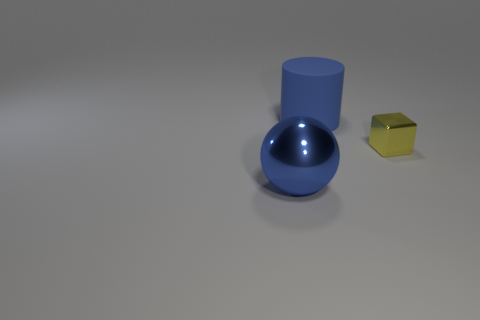How many objects are red cylinders or things that are right of the large metal ball?
Give a very brief answer. 2. Are the small thing and the big blue ball made of the same material?
Make the answer very short. Yes. Are there the same number of big blue things on the left side of the large blue metallic object and blue objects in front of the tiny metal thing?
Provide a short and direct response. No. What number of things are to the left of the yellow shiny thing?
Your response must be concise. 2. What number of things are big purple matte cylinders or large blue metal balls?
Give a very brief answer. 1. How many blue matte things have the same size as the blue sphere?
Make the answer very short. 1. There is a metal thing on the right side of the big blue thing in front of the small shiny thing; what is its shape?
Provide a succinct answer. Cube. Are there fewer red matte balls than blue balls?
Make the answer very short. Yes. There is a large object behind the blue shiny ball; what color is it?
Keep it short and to the point. Blue. There is a thing that is both to the right of the large blue ball and in front of the blue cylinder; what is it made of?
Ensure brevity in your answer.  Metal. 